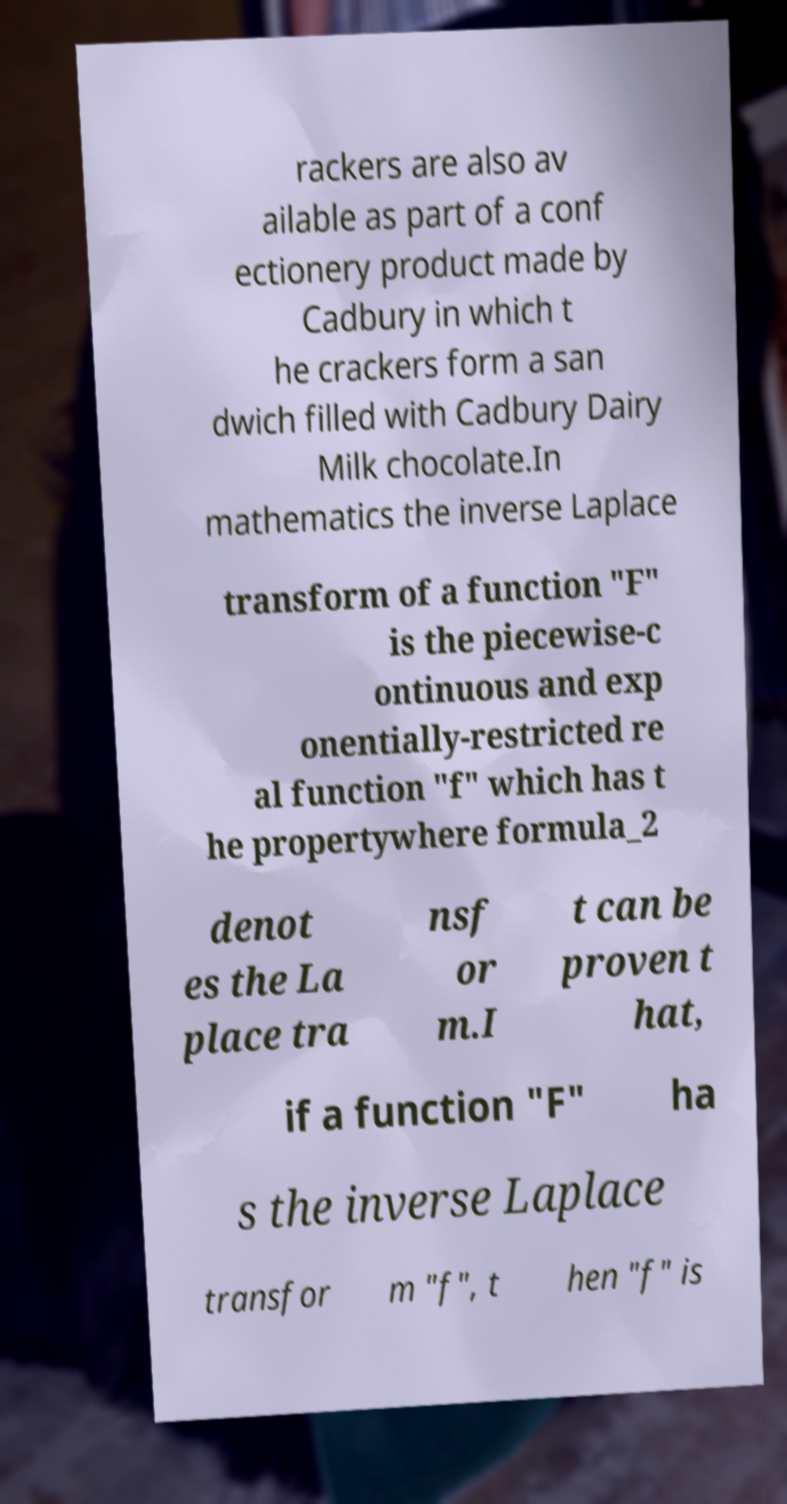What messages or text are displayed in this image? I need them in a readable, typed format. rackers are also av ailable as part of a conf ectionery product made by Cadbury in which t he crackers form a san dwich filled with Cadbury Dairy Milk chocolate.In mathematics the inverse Laplace transform of a function "F" is the piecewise-c ontinuous and exp onentially-restricted re al function "f" which has t he propertywhere formula_2 denot es the La place tra nsf or m.I t can be proven t hat, if a function "F" ha s the inverse Laplace transfor m "f", t hen "f" is 